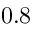Convert formula to latex. <formula><loc_0><loc_0><loc_500><loc_500>0 . 8</formula> 